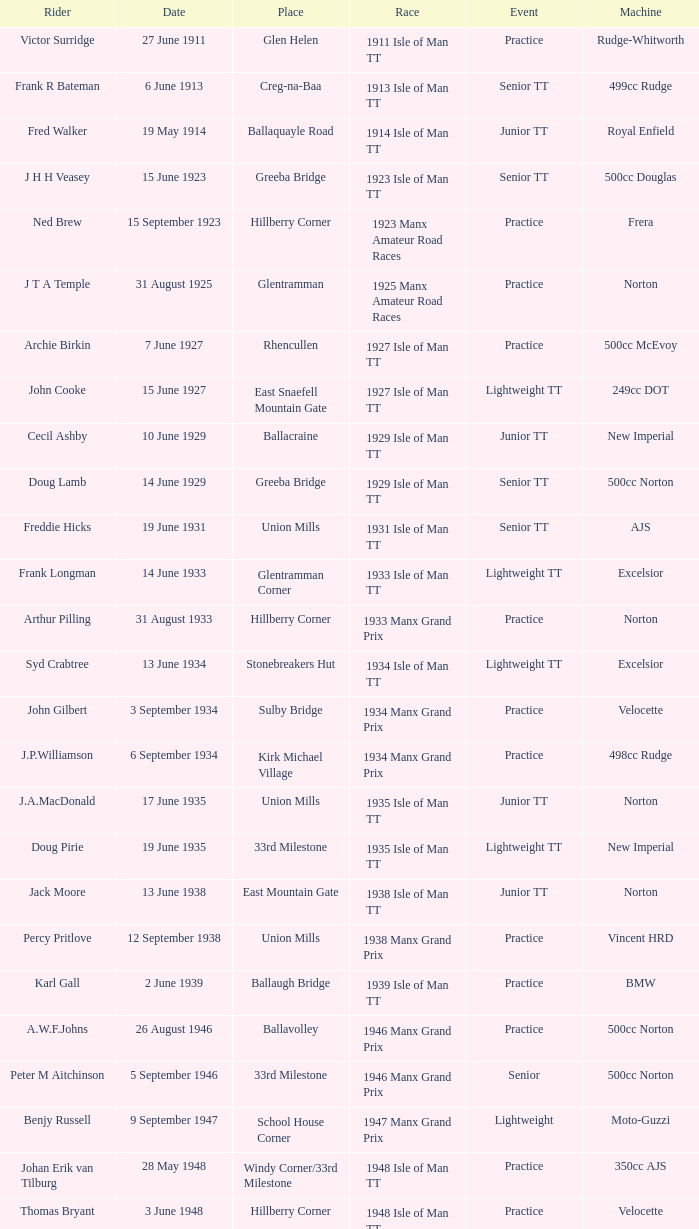Harry l stephen operates a norton device on which date? 8 June 1953. 